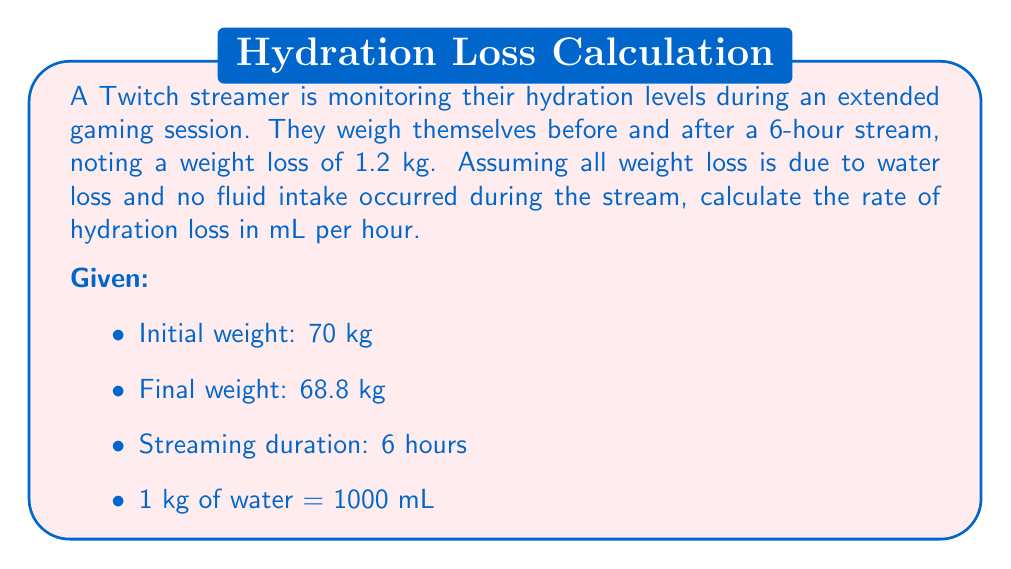Teach me how to tackle this problem. Let's break this problem down into steps:

1. Calculate the total water loss:
   $$\text{Water loss} = \text{Initial weight} - \text{Final weight}$$
   $$\text{Water loss} = 70 \text{ kg} - 68.8 \text{ kg} = 1.2 \text{ kg}$$

2. Convert the water loss from kg to mL:
   $$\text{Water loss in mL} = 1.2 \text{ kg} \times 1000 \text{ mL/kg} = 1200 \text{ mL}$$

3. Calculate the rate of hydration loss per hour:
   $$\text{Rate of hydration loss} = \frac{\text{Total water loss}}{\text{Duration of stream}}$$
   $$\text{Rate of hydration loss} = \frac{1200 \text{ mL}}{6 \text{ hours}}$$
   $$\text{Rate of hydration loss} = 200 \text{ mL/hour}$$

Therefore, the streamer is losing water at a rate of 200 mL per hour during their gaming session.
Answer: 200 mL/hour 